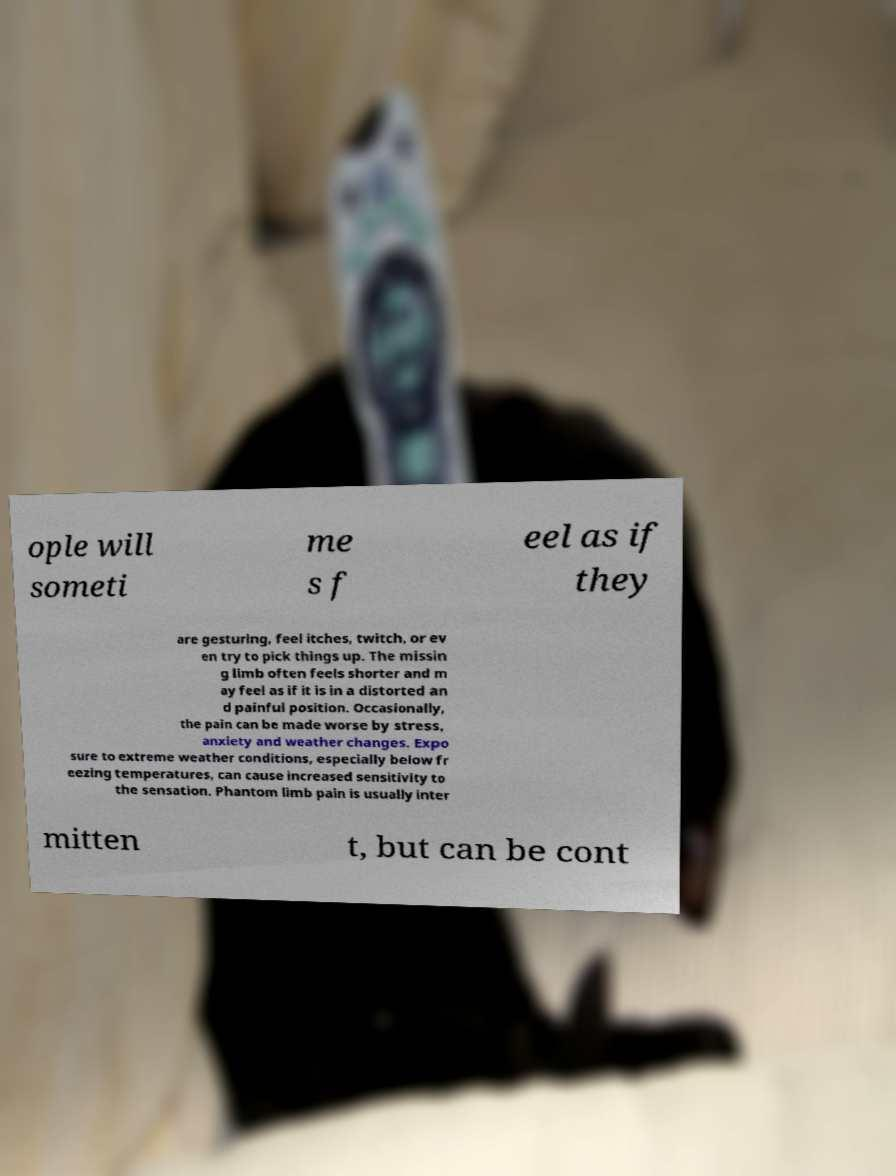Can you accurately transcribe the text from the provided image for me? ople will someti me s f eel as if they are gesturing, feel itches, twitch, or ev en try to pick things up. The missin g limb often feels shorter and m ay feel as if it is in a distorted an d painful position. Occasionally, the pain can be made worse by stress, anxiety and weather changes. Expo sure to extreme weather conditions, especially below fr eezing temperatures, can cause increased sensitivity to the sensation. Phantom limb pain is usually inter mitten t, but can be cont 